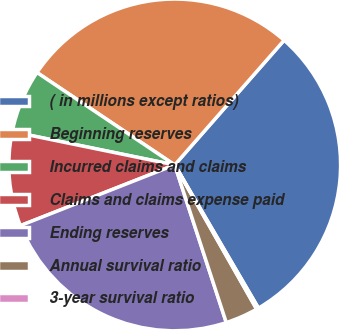Convert chart to OTSL. <chart><loc_0><loc_0><loc_500><loc_500><pie_chart><fcel>( in millions except ratios)<fcel>Beginning reserves<fcel>Incurred claims and claims<fcel>Claims and claims expense paid<fcel>Ending reserves<fcel>Annual survival ratio<fcel>3-year survival ratio<nl><fcel>30.12%<fcel>27.06%<fcel>6.19%<fcel>9.18%<fcel>24.07%<fcel>3.19%<fcel>0.2%<nl></chart> 